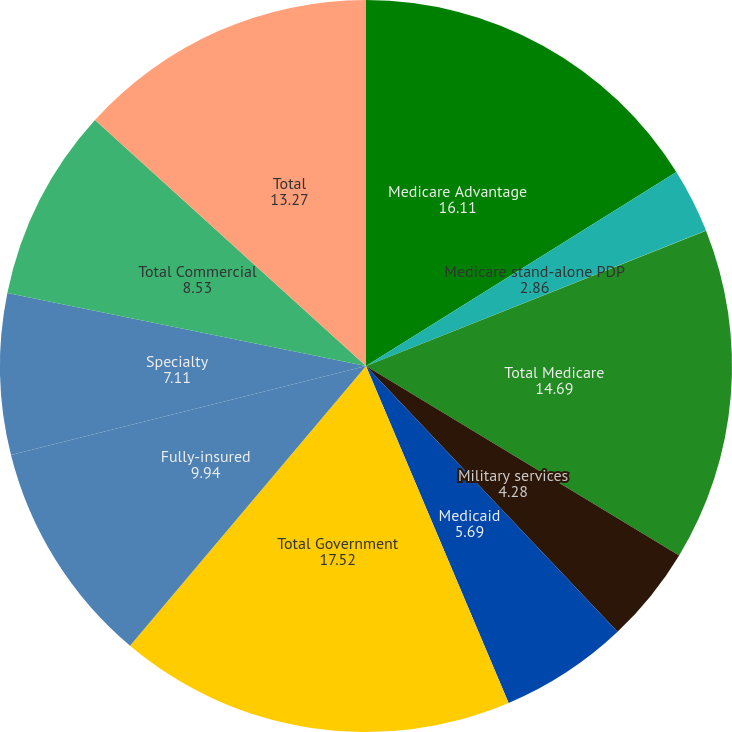Convert chart to OTSL. <chart><loc_0><loc_0><loc_500><loc_500><pie_chart><fcel>Medicare Advantage<fcel>Medicare stand-alone PDP<fcel>Total Medicare<fcel>Military services<fcel>Medicaid<fcel>Total Government<fcel>Fully-insured<fcel>Specialty<fcel>Total Commercial<fcel>Total<nl><fcel>16.11%<fcel>2.86%<fcel>14.69%<fcel>4.28%<fcel>5.69%<fcel>17.52%<fcel>9.94%<fcel>7.11%<fcel>8.53%<fcel>13.27%<nl></chart> 